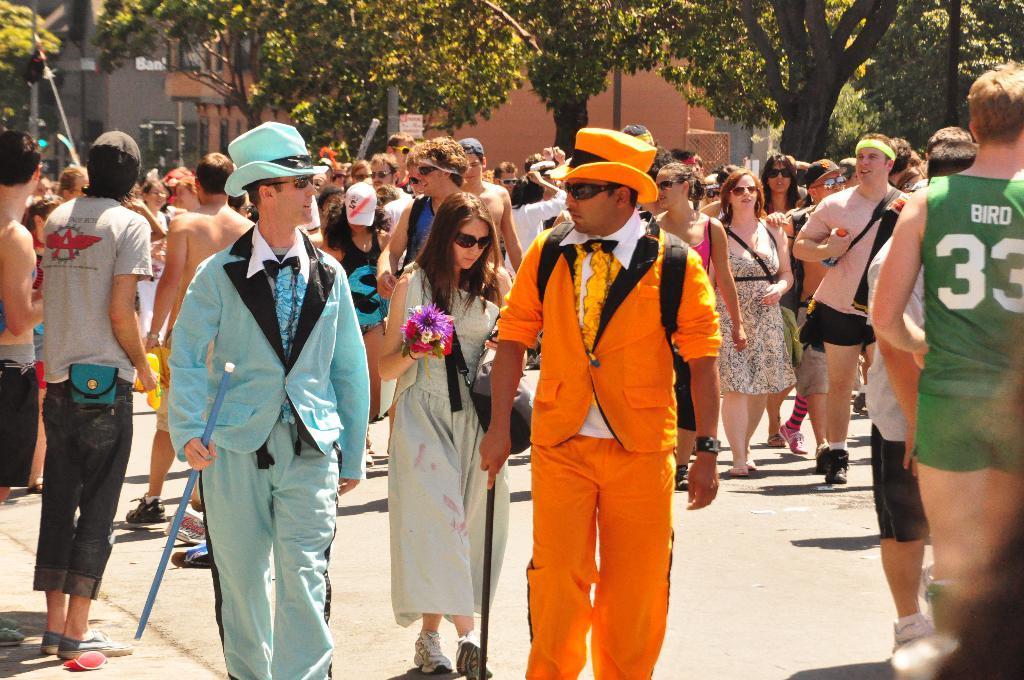Can you describe this image briefly? In the foreground of the picture there are people on the street. In the background there are trees, buildings, signal lights and other objects. 